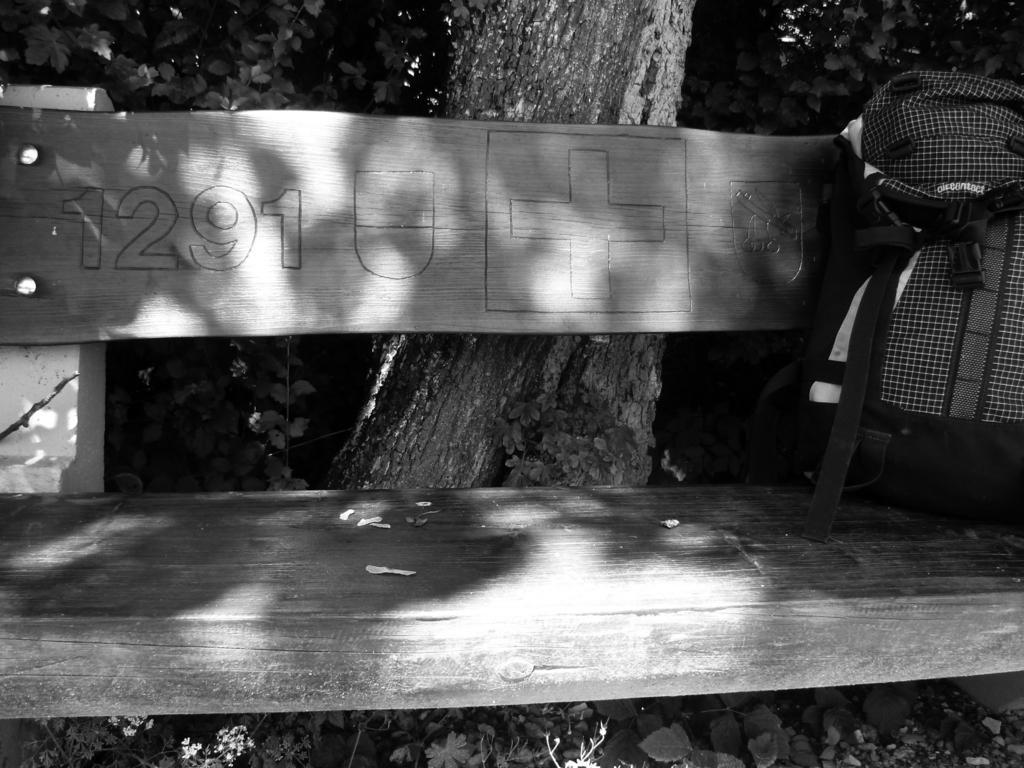Describe this image in one or two sentences. In this image I can see a wooden bench. On the bench I can see an object. In the background I can see a tree and plants. This picture is black and white in color. 